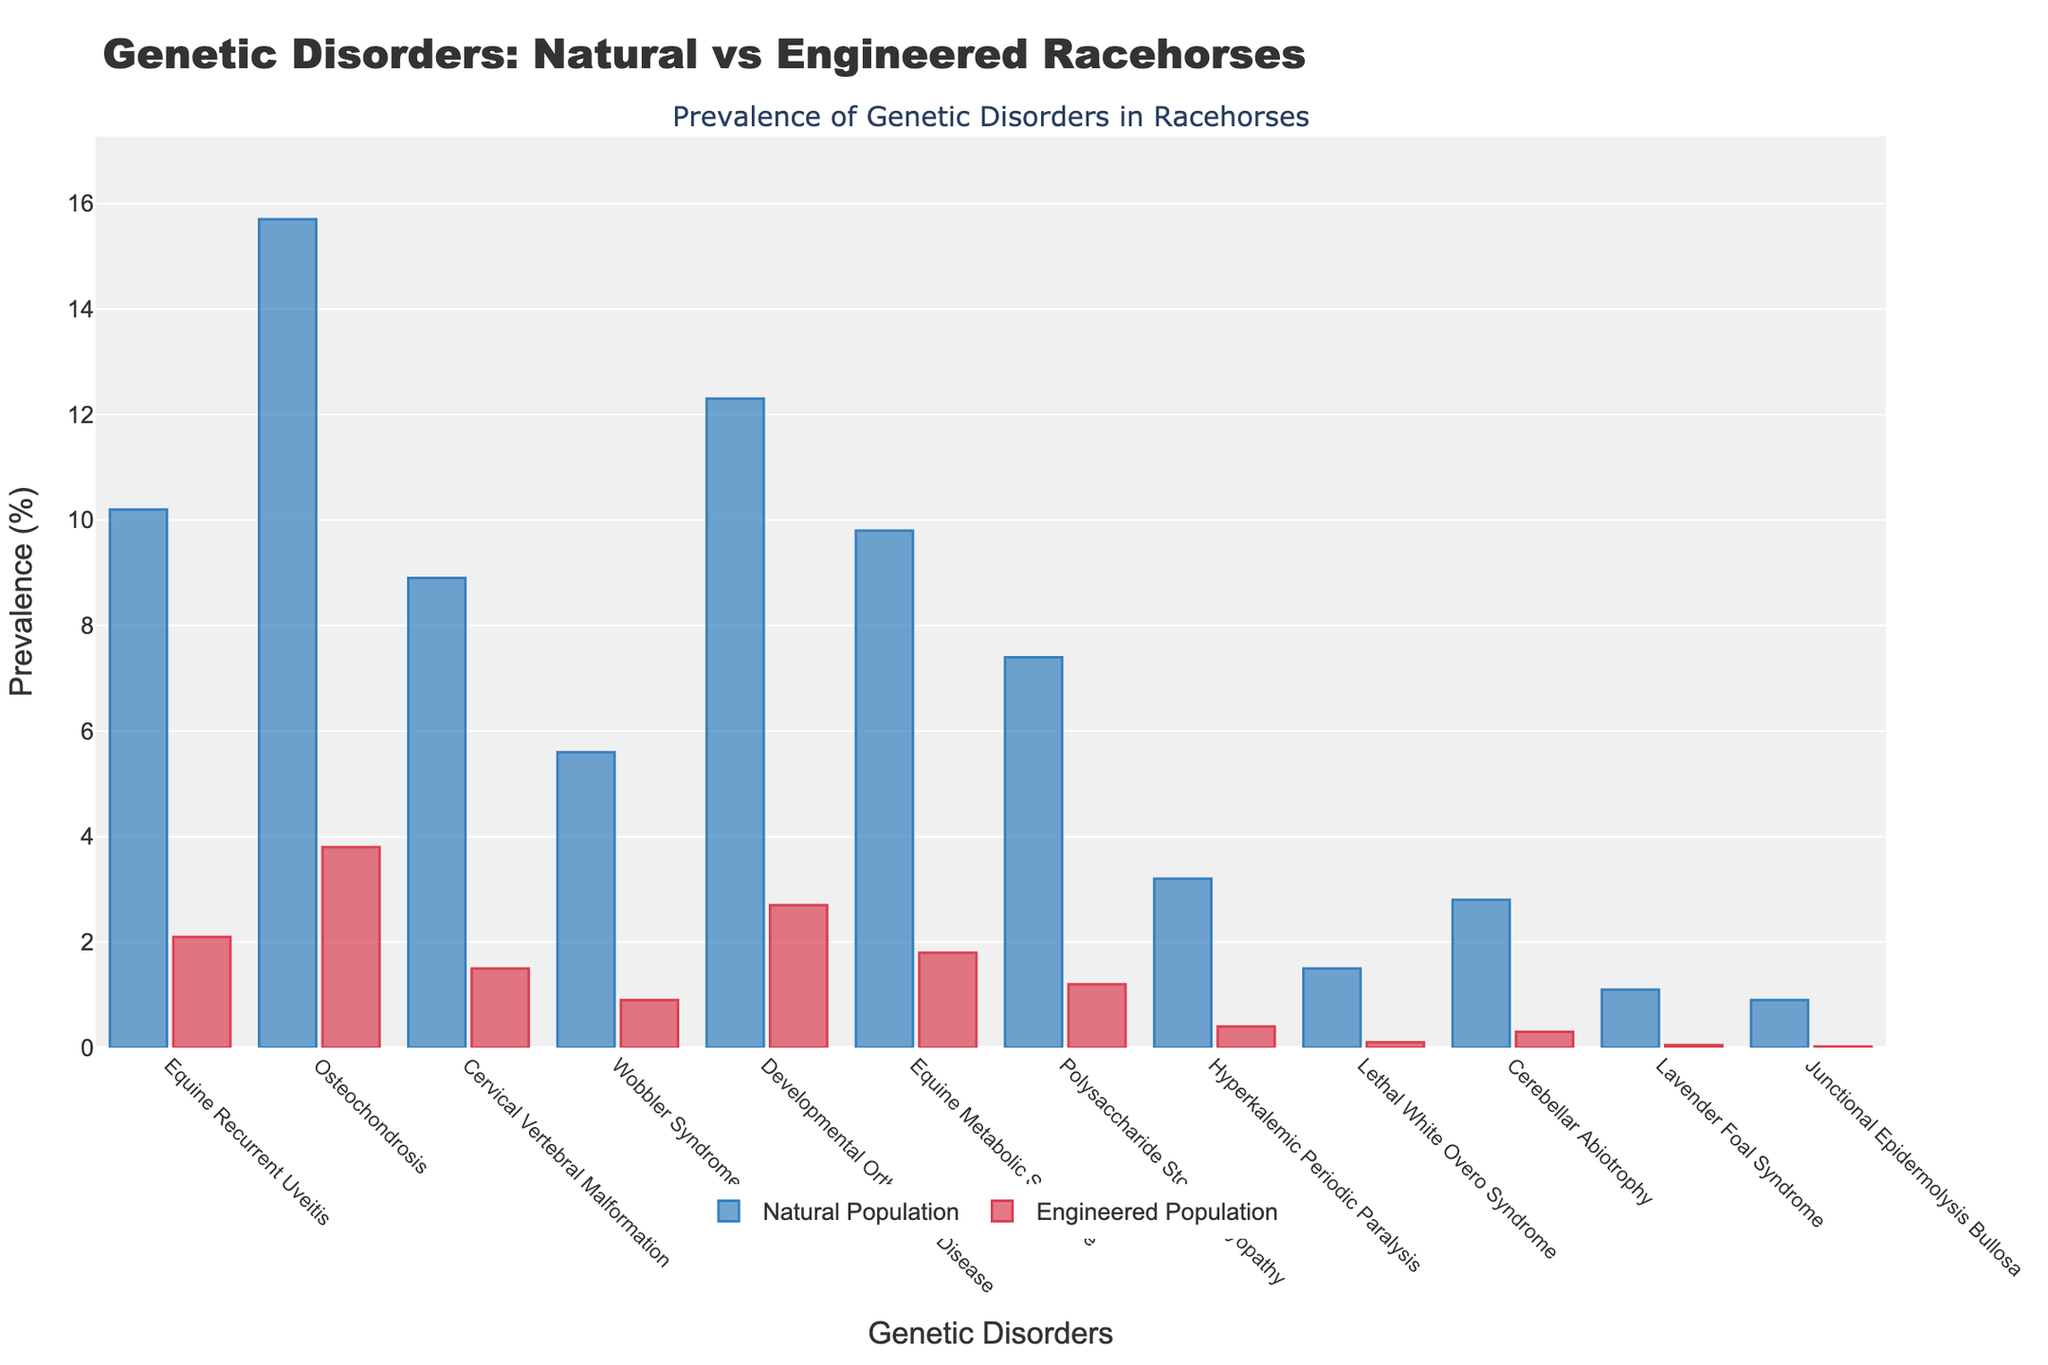What's the most prevalent genetic disorder in natural populations? By observing the height of the bars for natural populations, the disorder with the highest bar is "Osteochondrosis" at 15.7%.
Answer: Osteochondrosis Which genetic disorder shows the largest difference in prevalence between natural and engineered populations? To find the largest difference, subtract the values for natural populations from the engineered populations for each disorder. "Osteochondrosis" shows the largest difference with (15.7% - 3.8% = 11.9%).
Answer: Osteochondrosis What's the combined prevalence of "Cervical Vertebral Malformation" and "Wobbler Syndrome" in natural populations? Add the prevalence values for both disorders in natural populations. "Cervical Vertebral Malformation" is 8.9% and "Wobbler Syndrome" is 5.6%. Combined: 8.9% + 5.6% = 14.5%.
Answer: 14.5% Which genetic disorder has the lowest prevalence in engineered populations? By examining the height of the bars for engineered populations, the disorder with the lowest bar is "Junctional Epidermolysis Bullosa" at 0.02%.
Answer: Junctional Epidermolysis Bullosa How much greater is the prevalence of "Equine Recurrent Uveitis" in natural populations compared to engineered populations? Subtract the value for the engineered population from the value for the natural population. For "Equine Recurrent Uveitis", it is 10.2% - 2.1% = 8.1%.
Answer: 8.1% Calculate the average prevalence of disorders in engineered populations for "Equine Metabolic Syndrome," "Polysaccharide Storage Myopathy," and "Lavender Foal Syndrome." Add the prevalence values for these disorders in engineered populations and divide by the number of disorders. (1.8% + 1.2% + 0.05%) / 3 = 1.02%.
Answer: 1.02% Which genetic disorder shows the greatest prevalence reduction when comparing natural to engineered populations? Determine the reductions and compare them. "Osteochondrosis" has the greatest reduction: 15.7% in natural vs 3.8% in engineered, a reduction of 15.7% - 3.8% = 11.9%.
Answer: Osteochondrosis What is the difference in prevalence of "Cerebellar Abiotrophy" between natural and engineered populations? Subtract the value for the engineered population from the value for the natural population. For "Cerebellar Abiotrophy", it is 2.8% - 0.3% = 2.5%.
Answer: 2.5% Which population (natural or engineered) generally exhibits lower prevalence rates for these genetic disorders? Visually, the bars for the engineered population are consistently lower than those for the natural population, indicating typically lower prevalence rates.
Answer: Engineered 